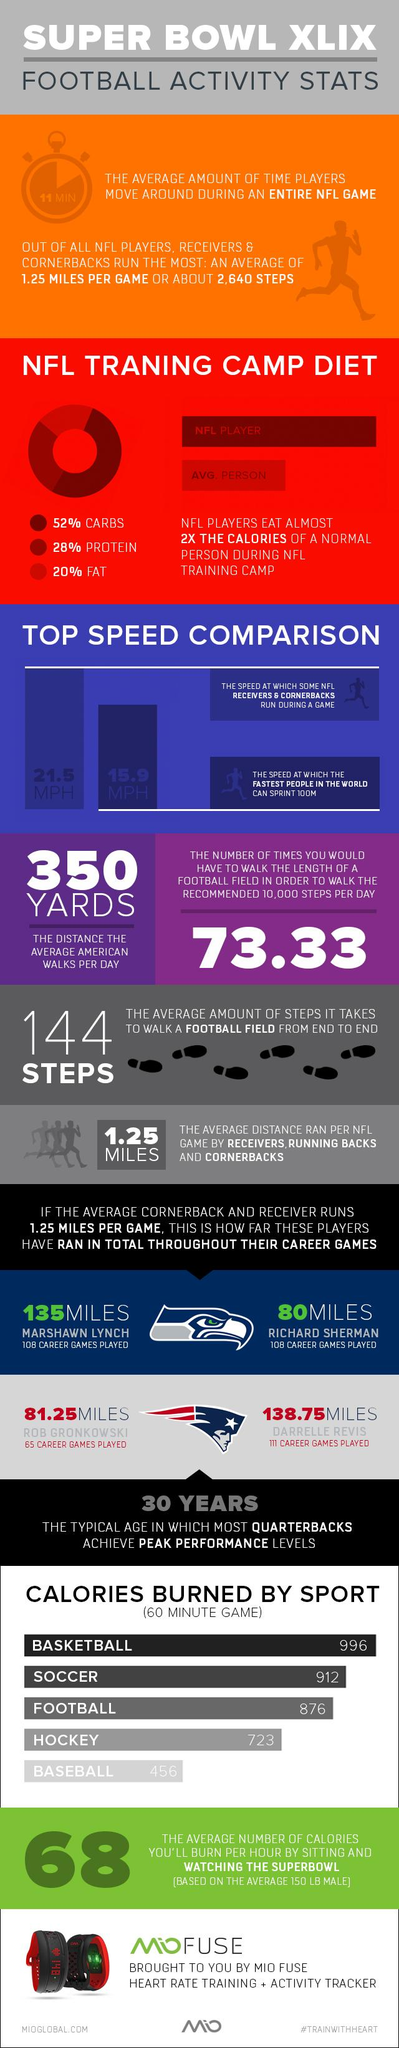List a handful of essential elements in this visual. Marshawn Lynch, a renowned NFL player, played for the Seattle Seahawks team. His exceptional skills and talent earned him a place in the hearts of fans, making him a beloved player among the team's supporters. Throughout his illustrious career, Lynch played for several teams, including the Green Bay Packers, Kansas City Chiefs, and Dallas Cowboys. However, his true home was with the Seattle Seahawks, where he gave his best performances and won the hearts of many. In his illustrious career, Richard Sherman played a grand total of 108 games. Several NFL receivers and cornerbacks are known to run at a speed of 21.5 MPH during games. The fastest people in the world can sprint 100m at a speed of 15.9 miles per hour. According to the recommended diet for NFL players during training camp, a sufficient amount of protein is essential for maintaining strength and endurance. It is recommended that players consume 28% of their daily calories from protein. 